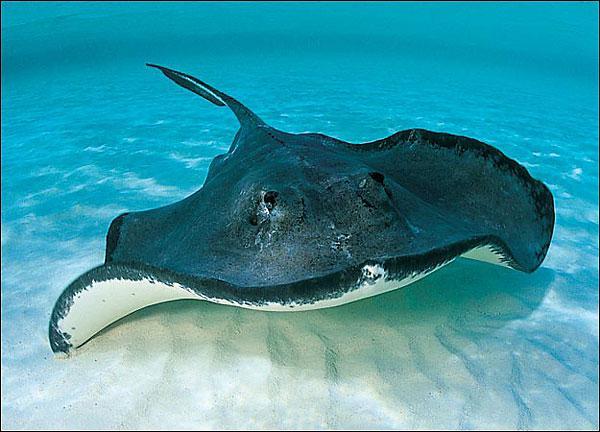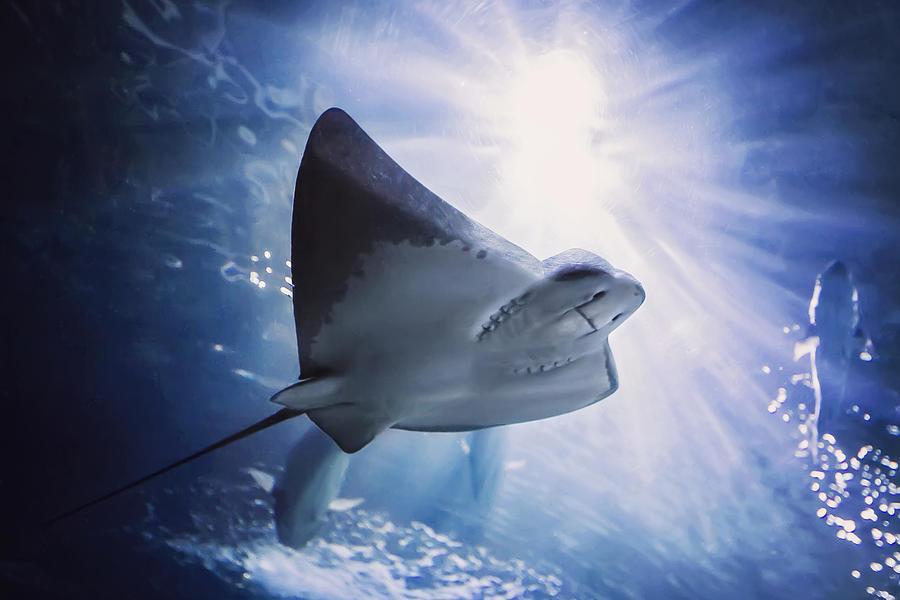The first image is the image on the left, the second image is the image on the right. Considering the images on both sides, is "Each image is a top-view of a stingray swimming close to the bottom of the ocean." valid? Answer yes or no. No. 